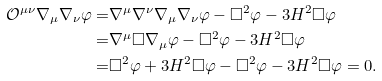<formula> <loc_0><loc_0><loc_500><loc_500>\mathcal { O } ^ { \mu \nu } \nabla _ { \mu } \nabla _ { \nu } \varphi = & \nabla ^ { \mu } \nabla ^ { \nu } \nabla _ { \mu } \nabla _ { \nu } \varphi - \square ^ { 2 } \varphi - 3 H ^ { 2 } \square \varphi \\ = & \nabla ^ { \mu } \square \nabla _ { \mu } \varphi - \square ^ { 2 } \varphi - 3 H ^ { 2 } \square \varphi \\ = & \square ^ { 2 } \varphi + 3 H ^ { 2 } \square \varphi - \square ^ { 2 } \varphi - 3 H ^ { 2 } \square \varphi = 0 .</formula> 